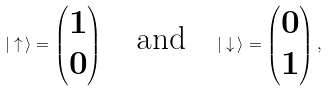<formula> <loc_0><loc_0><loc_500><loc_500>| \uparrow \, \rangle = \begin{pmatrix} 1 \\ 0 \end{pmatrix} \quad \text {and} \quad | \downarrow \, \rangle = \begin{pmatrix} 0 \\ 1 \end{pmatrix} ,</formula> 